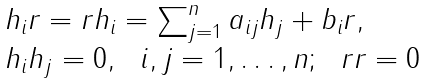<formula> <loc_0><loc_0><loc_500><loc_500>\begin{array} { l l } h _ { i } r = r h _ { i } = \sum _ { j = 1 } ^ { n } a _ { i j } h _ { j } + b _ { i } r , \\ h _ { i } h _ { j } = 0 , \ \ i , j = 1 , \dots , n ; \ \ r r = 0 \end{array}</formula> 